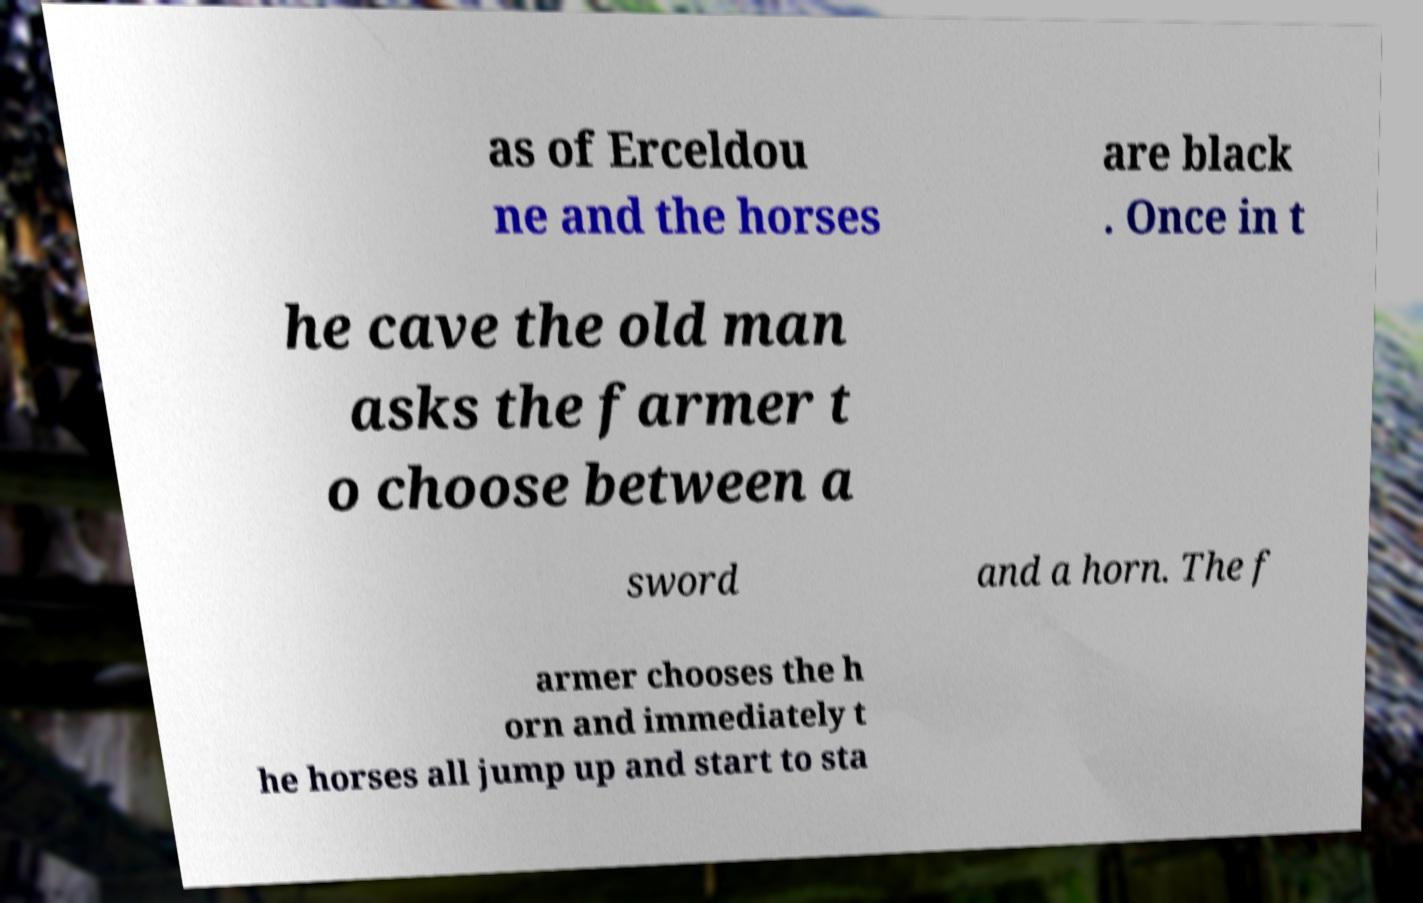Can you read and provide the text displayed in the image?This photo seems to have some interesting text. Can you extract and type it out for me? as of Erceldou ne and the horses are black . Once in t he cave the old man asks the farmer t o choose between a sword and a horn. The f armer chooses the h orn and immediately t he horses all jump up and start to sta 